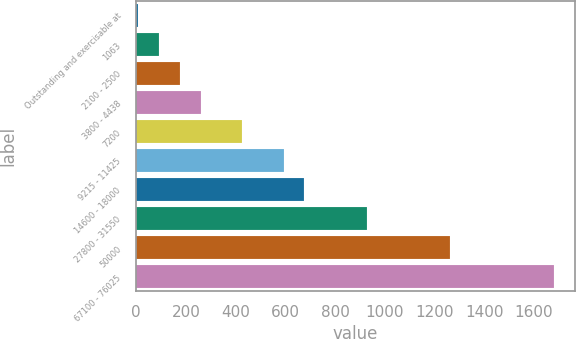<chart> <loc_0><loc_0><loc_500><loc_500><bar_chart><fcel>Outstanding and exercisable at<fcel>1063<fcel>2100 - 2500<fcel>3800 - 4438<fcel>7200<fcel>9215 - 11425<fcel>14600 - 18000<fcel>27800 - 31550<fcel>50000<fcel>67100 - 76025<nl><fcel>8.21<fcel>91.83<fcel>175.45<fcel>259.07<fcel>426.31<fcel>593.55<fcel>677.17<fcel>928.03<fcel>1262.51<fcel>1680.61<nl></chart> 